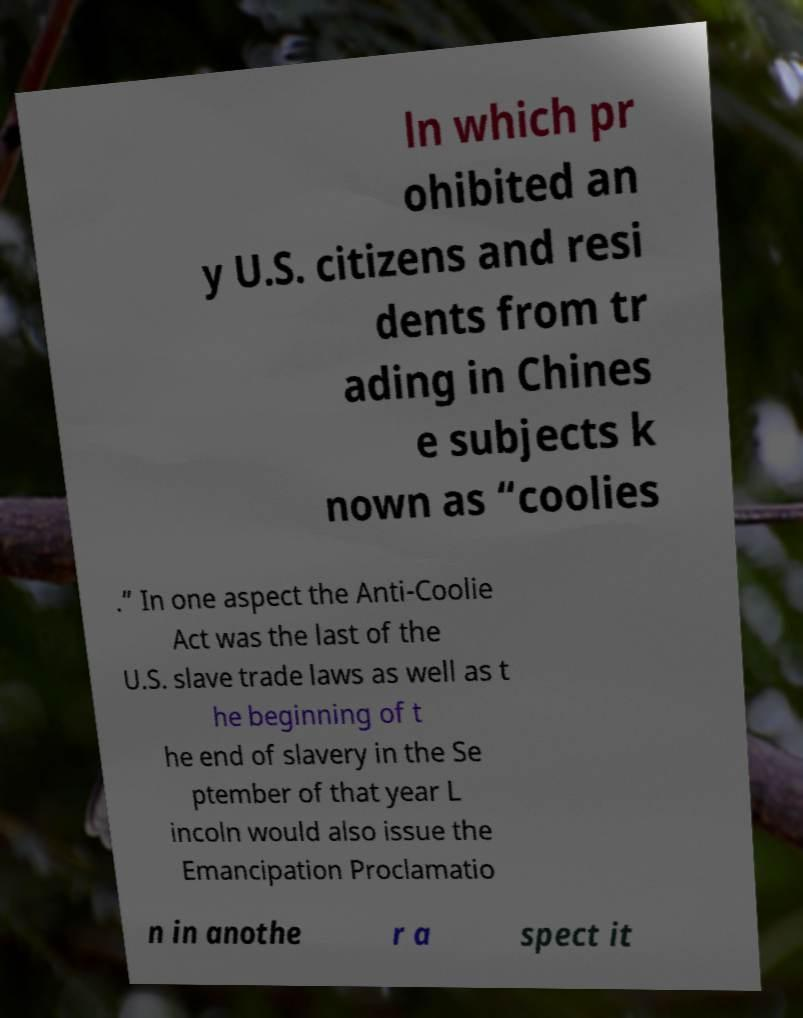Can you read and provide the text displayed in the image?This photo seems to have some interesting text. Can you extract and type it out for me? ln which pr ohibited an y U.S. citizens and resi dents from tr ading in Chines e subjects k nown as “coolies .” In one aspect the Anti-Coolie Act was the last of the U.S. slave trade laws as well as t he beginning of t he end of slavery in the Se ptember of that year L incoln would also issue the Emancipation Proclamatio n in anothe r a spect it 